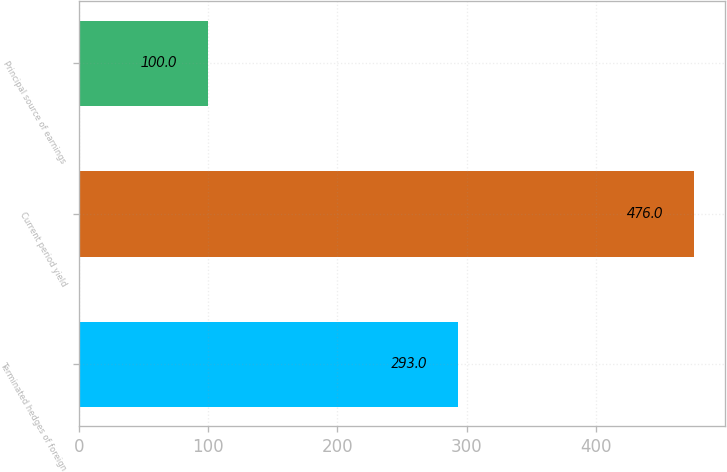<chart> <loc_0><loc_0><loc_500><loc_500><bar_chart><fcel>Terminated hedges of foreign<fcel>Current period yield<fcel>Principal source of earnings<nl><fcel>293<fcel>476<fcel>100<nl></chart> 